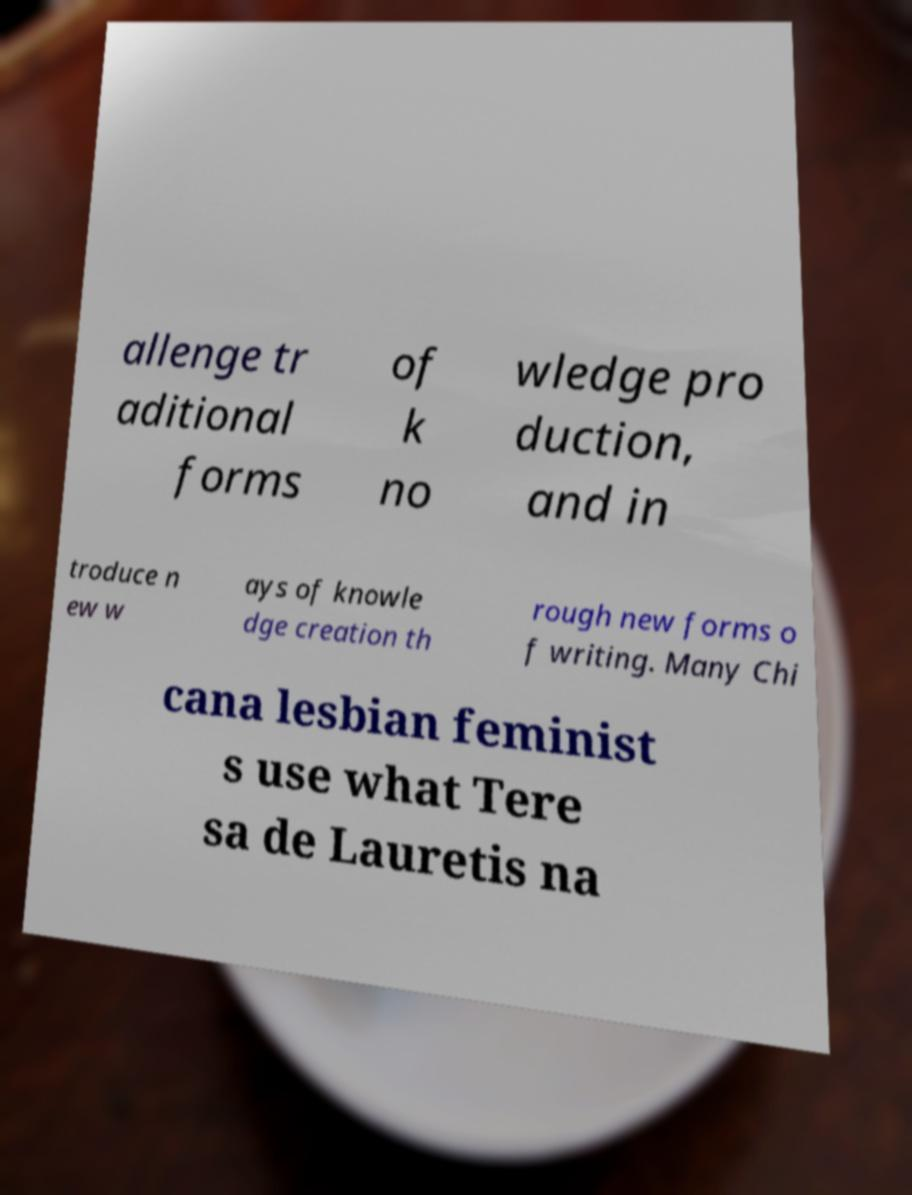For documentation purposes, I need the text within this image transcribed. Could you provide that? allenge tr aditional forms of k no wledge pro duction, and in troduce n ew w ays of knowle dge creation th rough new forms o f writing. Many Chi cana lesbian feminist s use what Tere sa de Lauretis na 